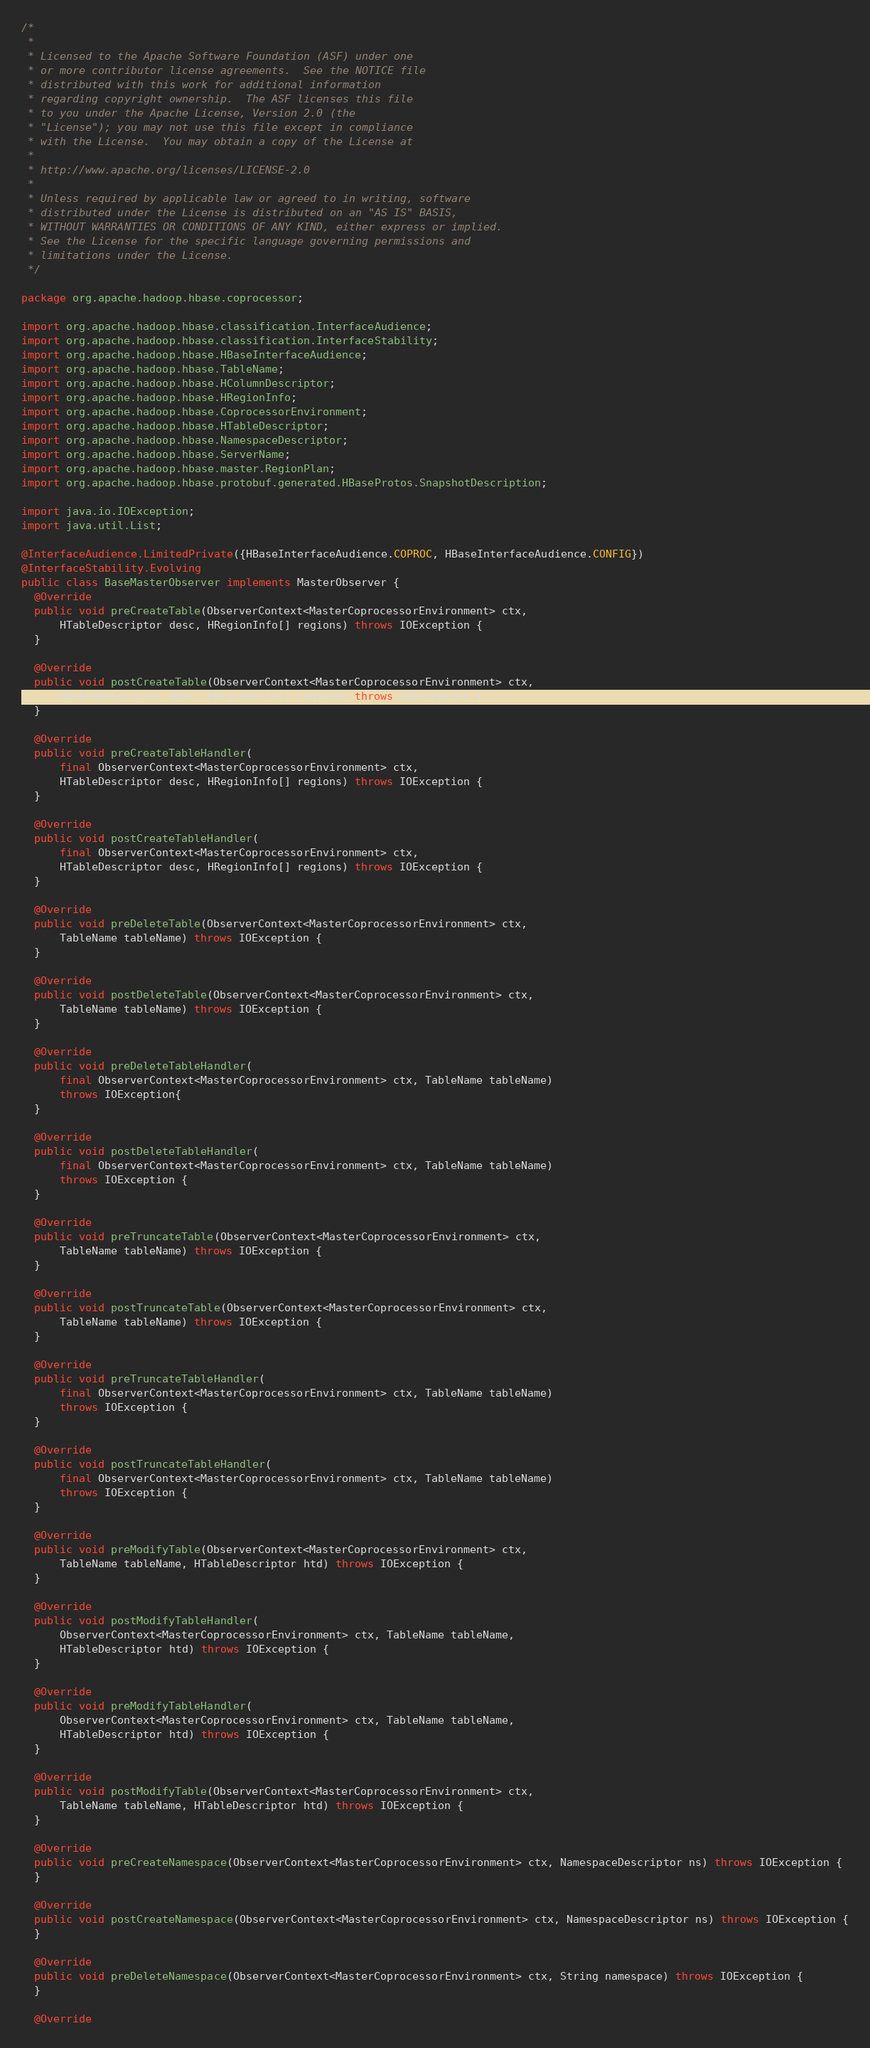Convert code to text. <code><loc_0><loc_0><loc_500><loc_500><_Java_>/*
 *
 * Licensed to the Apache Software Foundation (ASF) under one
 * or more contributor license agreements.  See the NOTICE file
 * distributed with this work for additional information
 * regarding copyright ownership.  The ASF licenses this file
 * to you under the Apache License, Version 2.0 (the
 * "License"); you may not use this file except in compliance
 * with the License.  You may obtain a copy of the License at
 *
 * http://www.apache.org/licenses/LICENSE-2.0
 *
 * Unless required by applicable law or agreed to in writing, software
 * distributed under the License is distributed on an "AS IS" BASIS,
 * WITHOUT WARRANTIES OR CONDITIONS OF ANY KIND, either express or implied.
 * See the License for the specific language governing permissions and
 * limitations under the License.
 */

package org.apache.hadoop.hbase.coprocessor;

import org.apache.hadoop.hbase.classification.InterfaceAudience;
import org.apache.hadoop.hbase.classification.InterfaceStability;
import org.apache.hadoop.hbase.HBaseInterfaceAudience;
import org.apache.hadoop.hbase.TableName;
import org.apache.hadoop.hbase.HColumnDescriptor;
import org.apache.hadoop.hbase.HRegionInfo;
import org.apache.hadoop.hbase.CoprocessorEnvironment;
import org.apache.hadoop.hbase.HTableDescriptor;
import org.apache.hadoop.hbase.NamespaceDescriptor;
import org.apache.hadoop.hbase.ServerName;
import org.apache.hadoop.hbase.master.RegionPlan;
import org.apache.hadoop.hbase.protobuf.generated.HBaseProtos.SnapshotDescription;

import java.io.IOException;
import java.util.List;

@InterfaceAudience.LimitedPrivate({HBaseInterfaceAudience.COPROC, HBaseInterfaceAudience.CONFIG})
@InterfaceStability.Evolving
public class BaseMasterObserver implements MasterObserver {
  @Override
  public void preCreateTable(ObserverContext<MasterCoprocessorEnvironment> ctx,
      HTableDescriptor desc, HRegionInfo[] regions) throws IOException {
  }

  @Override
  public void postCreateTable(ObserverContext<MasterCoprocessorEnvironment> ctx,
      HTableDescriptor desc, HRegionInfo[] regions) throws IOException {
  }

  @Override
  public void preCreateTableHandler(
      final ObserverContext<MasterCoprocessorEnvironment> ctx,
      HTableDescriptor desc, HRegionInfo[] regions) throws IOException {
  }

  @Override
  public void postCreateTableHandler(
      final ObserverContext<MasterCoprocessorEnvironment> ctx,
      HTableDescriptor desc, HRegionInfo[] regions) throws IOException {
  }

  @Override
  public void preDeleteTable(ObserverContext<MasterCoprocessorEnvironment> ctx,
      TableName tableName) throws IOException {
  }

  @Override
  public void postDeleteTable(ObserverContext<MasterCoprocessorEnvironment> ctx,
      TableName tableName) throws IOException {
  }

  @Override
  public void preDeleteTableHandler(
      final ObserverContext<MasterCoprocessorEnvironment> ctx, TableName tableName)
      throws IOException{
  }

  @Override
  public void postDeleteTableHandler(
      final ObserverContext<MasterCoprocessorEnvironment> ctx, TableName tableName)
      throws IOException {
  }

  @Override
  public void preTruncateTable(ObserverContext<MasterCoprocessorEnvironment> ctx,
      TableName tableName) throws IOException {
  }

  @Override
  public void postTruncateTable(ObserverContext<MasterCoprocessorEnvironment> ctx,
      TableName tableName) throws IOException {
  }

  @Override
  public void preTruncateTableHandler(
      final ObserverContext<MasterCoprocessorEnvironment> ctx, TableName tableName)
      throws IOException {
  }

  @Override
  public void postTruncateTableHandler(
      final ObserverContext<MasterCoprocessorEnvironment> ctx, TableName tableName)
      throws IOException {
  }

  @Override
  public void preModifyTable(ObserverContext<MasterCoprocessorEnvironment> ctx,
      TableName tableName, HTableDescriptor htd) throws IOException {
  }

  @Override
  public void postModifyTableHandler(
      ObserverContext<MasterCoprocessorEnvironment> ctx, TableName tableName,
      HTableDescriptor htd) throws IOException {
  }

  @Override
  public void preModifyTableHandler(
      ObserverContext<MasterCoprocessorEnvironment> ctx, TableName tableName,
      HTableDescriptor htd) throws IOException {
  }

  @Override
  public void postModifyTable(ObserverContext<MasterCoprocessorEnvironment> ctx,
      TableName tableName, HTableDescriptor htd) throws IOException {
  }

  @Override
  public void preCreateNamespace(ObserverContext<MasterCoprocessorEnvironment> ctx, NamespaceDescriptor ns) throws IOException {
  }

  @Override
  public void postCreateNamespace(ObserverContext<MasterCoprocessorEnvironment> ctx, NamespaceDescriptor ns) throws IOException {
  }

  @Override
  public void preDeleteNamespace(ObserverContext<MasterCoprocessorEnvironment> ctx, String namespace) throws IOException {
  }

  @Override</code> 